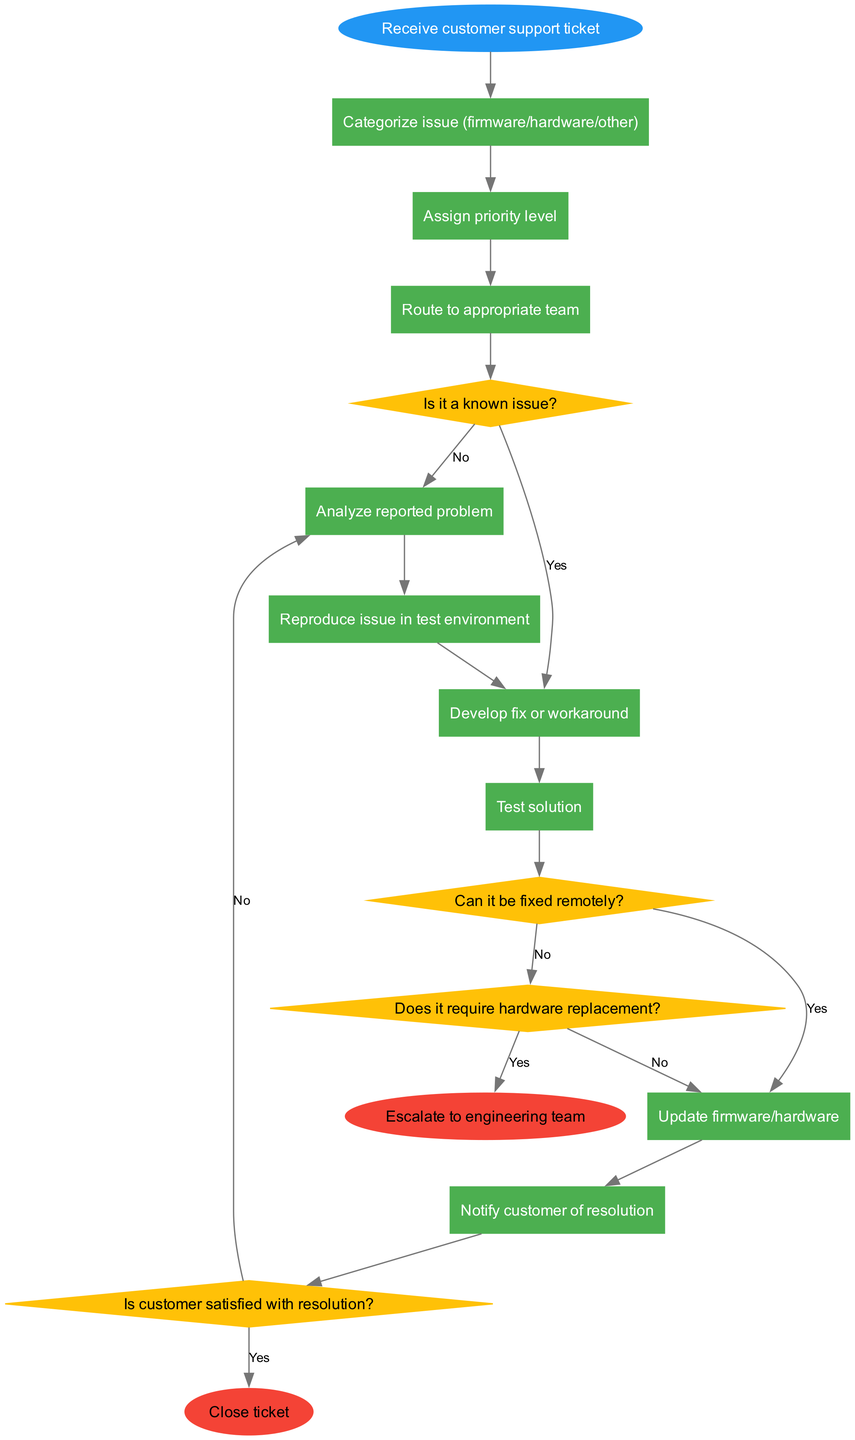What is the first step in the flow chart? The first step in the flow chart is to "Receive customer support ticket," as indicated by the start node.
Answer: Receive customer support ticket How many decision nodes are there in the diagram? The diagram contains four decision nodes: "Is it a known issue?", "Can it be fixed remotely?", "Does it require hardware replacement?", and "Is customer satisfied with resolution?"
Answer: Four What happens if the initial analysis shows that it is a known issue? If the initial analysis shows that it is a known issue, the flow proceeds to develop a fix or workaround, as indicated by the edge labeled "Yes" from the decision node.
Answer: Develop fix or workaround What is the last processing step before notifying the customer? The last processing step before notifying the customer is to "Update firmware/hardware," which is reached after successfully testing the solution.
Answer: Update firmware/hardware What is the outcome if a hardware replacement is required? If a hardware replacement is required, the flow directs to "Escalate to engineering team," as per the diagram's routing from the relevant decision node.
Answer: Escalate to engineering team What is the total number of processes listed in the flow chart? There are eight processes listed in the flow chart, starting from issue categorization to notifying the customer.
Answer: Eight What leads to closing the support ticket? The support ticket is closed if the customer is satisfied with the resolution, as indicated by the edge "Yes" from the final decision node.
Answer: Close ticket If the issue can be fixed remotely, which step follows? If the issue can be fixed remotely, the next step is to "Update firmware/hardware," as directed by the flow process if the decision is "Yes."
Answer: Update firmware/hardware 